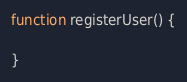<code> <loc_0><loc_0><loc_500><loc_500><_JavaScript_>function registerUser() {
    
}</code> 